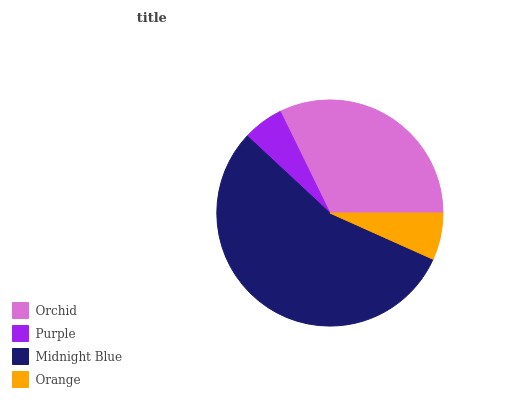Is Purple the minimum?
Answer yes or no. Yes. Is Midnight Blue the maximum?
Answer yes or no. Yes. Is Midnight Blue the minimum?
Answer yes or no. No. Is Purple the maximum?
Answer yes or no. No. Is Midnight Blue greater than Purple?
Answer yes or no. Yes. Is Purple less than Midnight Blue?
Answer yes or no. Yes. Is Purple greater than Midnight Blue?
Answer yes or no. No. Is Midnight Blue less than Purple?
Answer yes or no. No. Is Orchid the high median?
Answer yes or no. Yes. Is Orange the low median?
Answer yes or no. Yes. Is Purple the high median?
Answer yes or no. No. Is Orchid the low median?
Answer yes or no. No. 